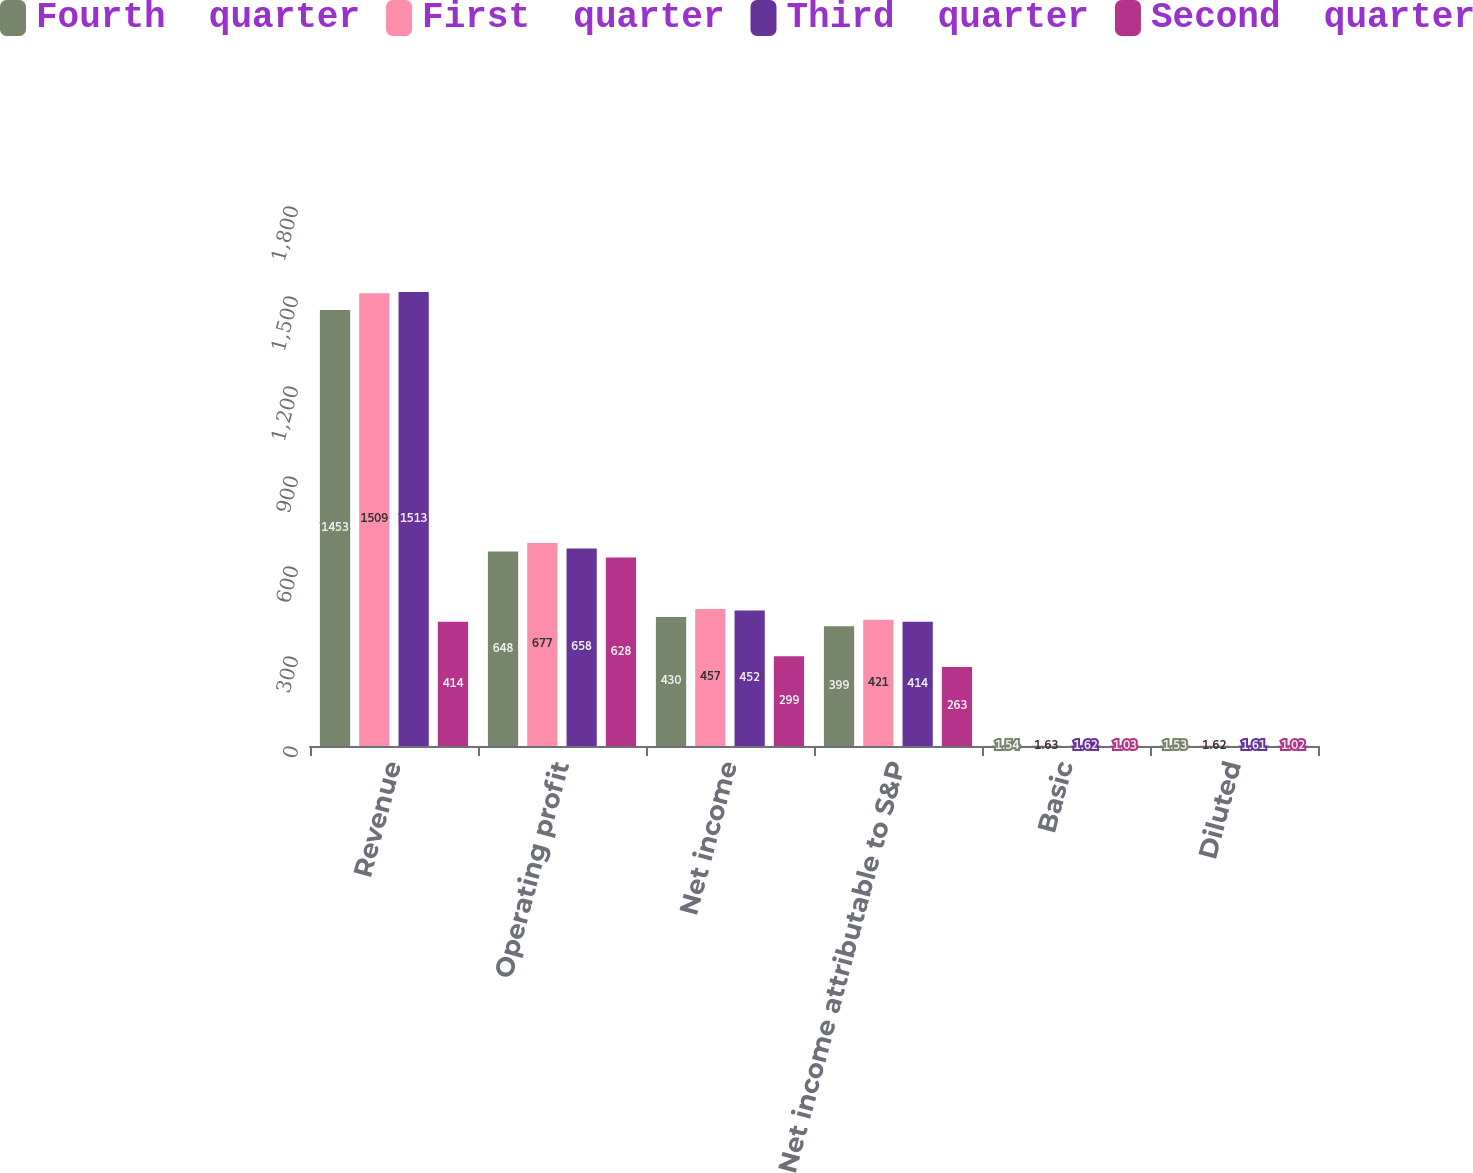<chart> <loc_0><loc_0><loc_500><loc_500><stacked_bar_chart><ecel><fcel>Revenue<fcel>Operating profit<fcel>Net income<fcel>Net income attributable to S&P<fcel>Basic<fcel>Diluted<nl><fcel>Fourth  quarter<fcel>1453<fcel>648<fcel>430<fcel>399<fcel>1.54<fcel>1.53<nl><fcel>First  quarter<fcel>1509<fcel>677<fcel>457<fcel>421<fcel>1.63<fcel>1.62<nl><fcel>Third  quarter<fcel>1513<fcel>658<fcel>452<fcel>414<fcel>1.62<fcel>1.61<nl><fcel>Second  quarter<fcel>414<fcel>628<fcel>299<fcel>263<fcel>1.03<fcel>1.02<nl></chart> 